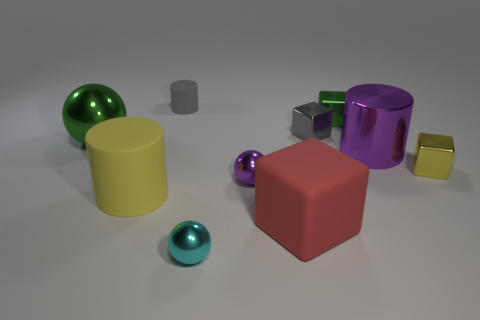How many big objects are yellow shiny cubes or yellow matte things?
Give a very brief answer. 1. Is the gray cylinder to the left of the large metallic cylinder made of the same material as the small purple thing?
Ensure brevity in your answer.  No. What is the color of the rubber cylinder behind the gray block?
Keep it short and to the point. Gray. Is there a gray shiny object of the same size as the yellow rubber thing?
Offer a terse response. No. What material is the purple cylinder that is the same size as the green shiny ball?
Your answer should be very brief. Metal. There is a cyan shiny sphere; is its size the same as the yellow thing to the right of the big yellow cylinder?
Your answer should be compact. Yes. There is a sphere that is to the left of the gray matte object; what material is it?
Keep it short and to the point. Metal. Are there an equal number of gray metallic objects left of the tiny purple metal ball and small brown rubber cylinders?
Offer a terse response. Yes. Do the green shiny block and the green metallic ball have the same size?
Offer a very short reply. No. Are there any small cyan shiny things that are in front of the rubber cylinder that is in front of the large green object that is to the left of the small cyan metallic object?
Your answer should be compact. Yes. 